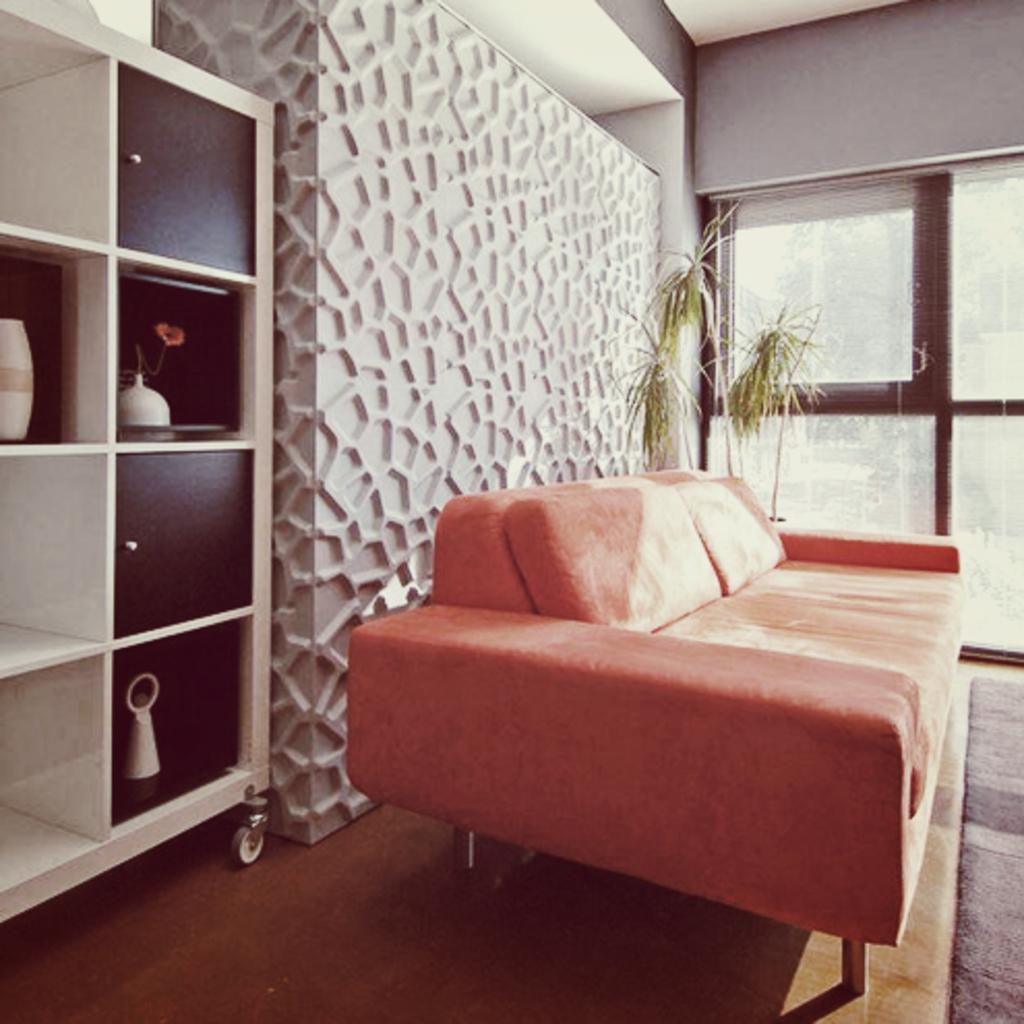Please provide a concise description of this image. In this image there is a bed. On top of the bed there are cushions. Behind the bed there are plants. On the left side of the image there are some objects on the wooden rack. At the bottom of the image there is a mat on the floor. In the background of the image there are glass windows. 